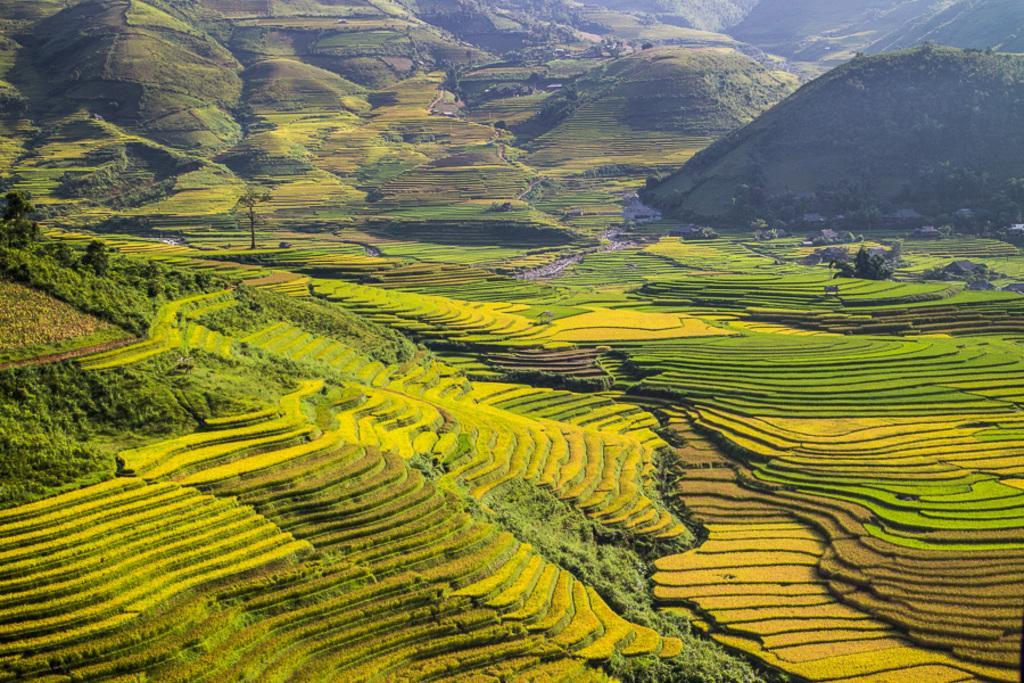How would you summarize this image in a sentence or two? In this picture there is a green farmland. Behind there are some mountains and trees. 